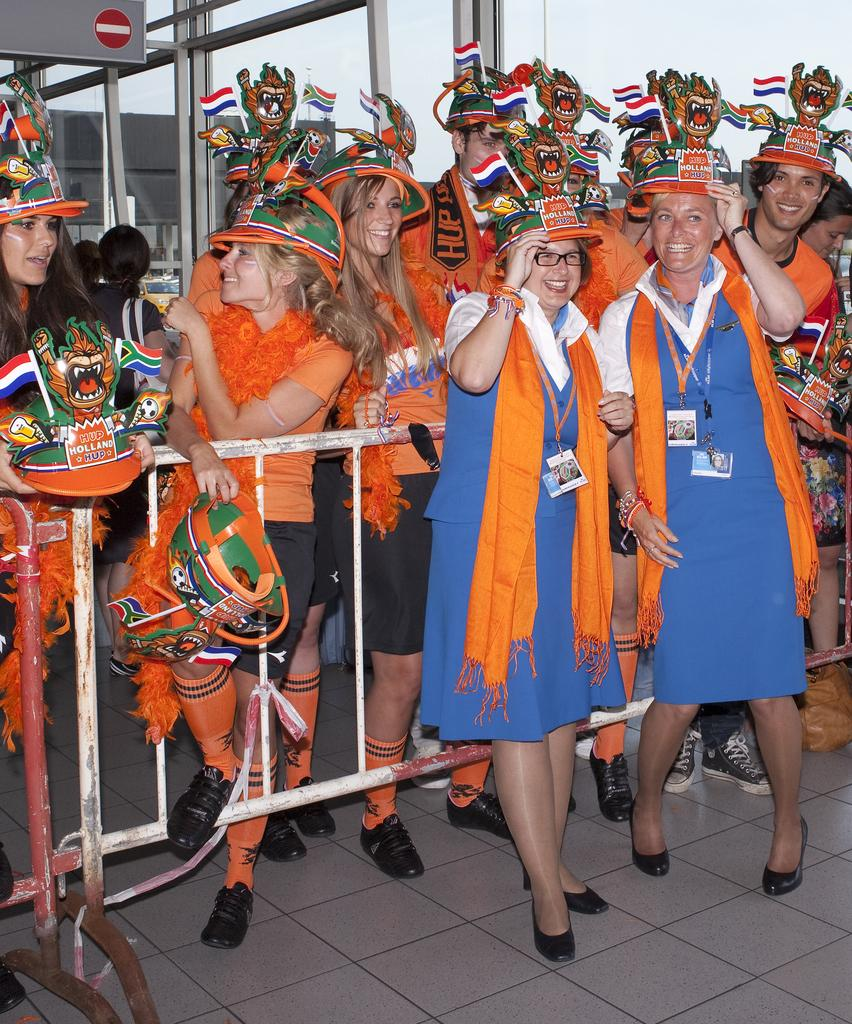How many people are in the image? There are many people standing in the image. What are the people wearing on their feet? The people are wearing shoes. What type of clothing are the people wearing on their lower body? The people are wearing pants. What is the general expression of the people in the image? The people are smiling. What is the surface that the people are standing on? There is a floor visible in the image. What type of barrier can be seen in the image? There is a barrier in the image. What is the transparent structure visible in the image? There is a glass window in the image. What is visible in the background of the image? The sky is visible in the image. What type of produce is being harvested by the people in the image? There is no produce or harvesting activity depicted in the image. How many hands are visible in the image? The number of hands cannot be determined from the image, as it only shows the people from the waist up. 